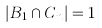<formula> <loc_0><loc_0><loc_500><loc_500>| B _ { 1 } \cap C _ { n } | = 1</formula> 